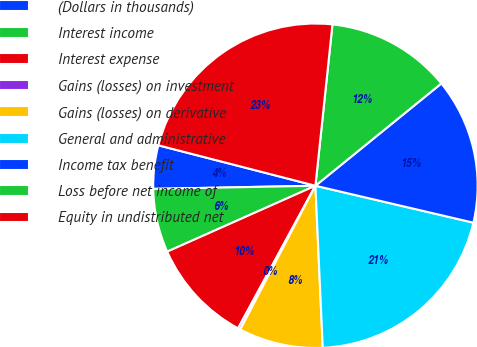Convert chart to OTSL. <chart><loc_0><loc_0><loc_500><loc_500><pie_chart><fcel>(Dollars in thousands)<fcel>Interest income<fcel>Interest expense<fcel>Gains (losses) on investment<fcel>Gains (losses) on derivative<fcel>General and administrative<fcel>Income tax benefit<fcel>Loss before net income of<fcel>Equity in undistributed net<nl><fcel>4.32%<fcel>6.35%<fcel>10.43%<fcel>0.24%<fcel>8.39%<fcel>20.62%<fcel>14.51%<fcel>12.47%<fcel>22.66%<nl></chart> 